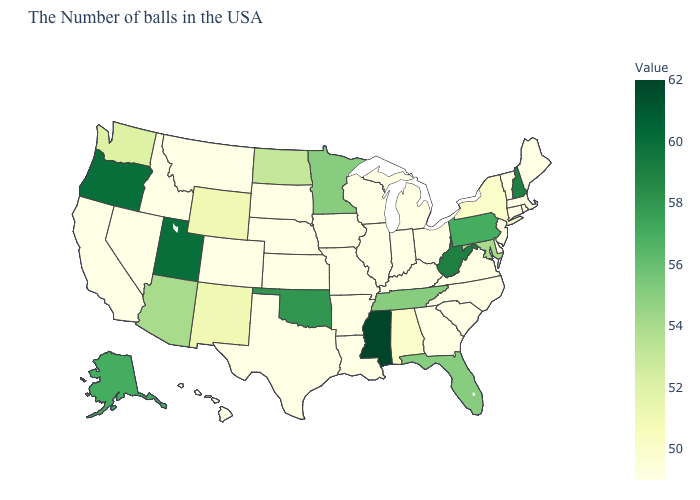Is the legend a continuous bar?
Answer briefly. Yes. Is the legend a continuous bar?
Be succinct. Yes. Which states have the lowest value in the USA?
Write a very short answer. Maine, Massachusetts, Rhode Island, Vermont, Connecticut, New Jersey, Delaware, Virginia, North Carolina, South Carolina, Ohio, Georgia, Michigan, Kentucky, Indiana, Wisconsin, Illinois, Louisiana, Missouri, Arkansas, Iowa, Kansas, Nebraska, Texas, South Dakota, Colorado, Montana, Idaho, Nevada, California, Hawaii. Does Rhode Island have the lowest value in the USA?
Quick response, please. Yes. Does Utah have a higher value than Mississippi?
Give a very brief answer. No. Which states have the highest value in the USA?
Give a very brief answer. Mississippi. 